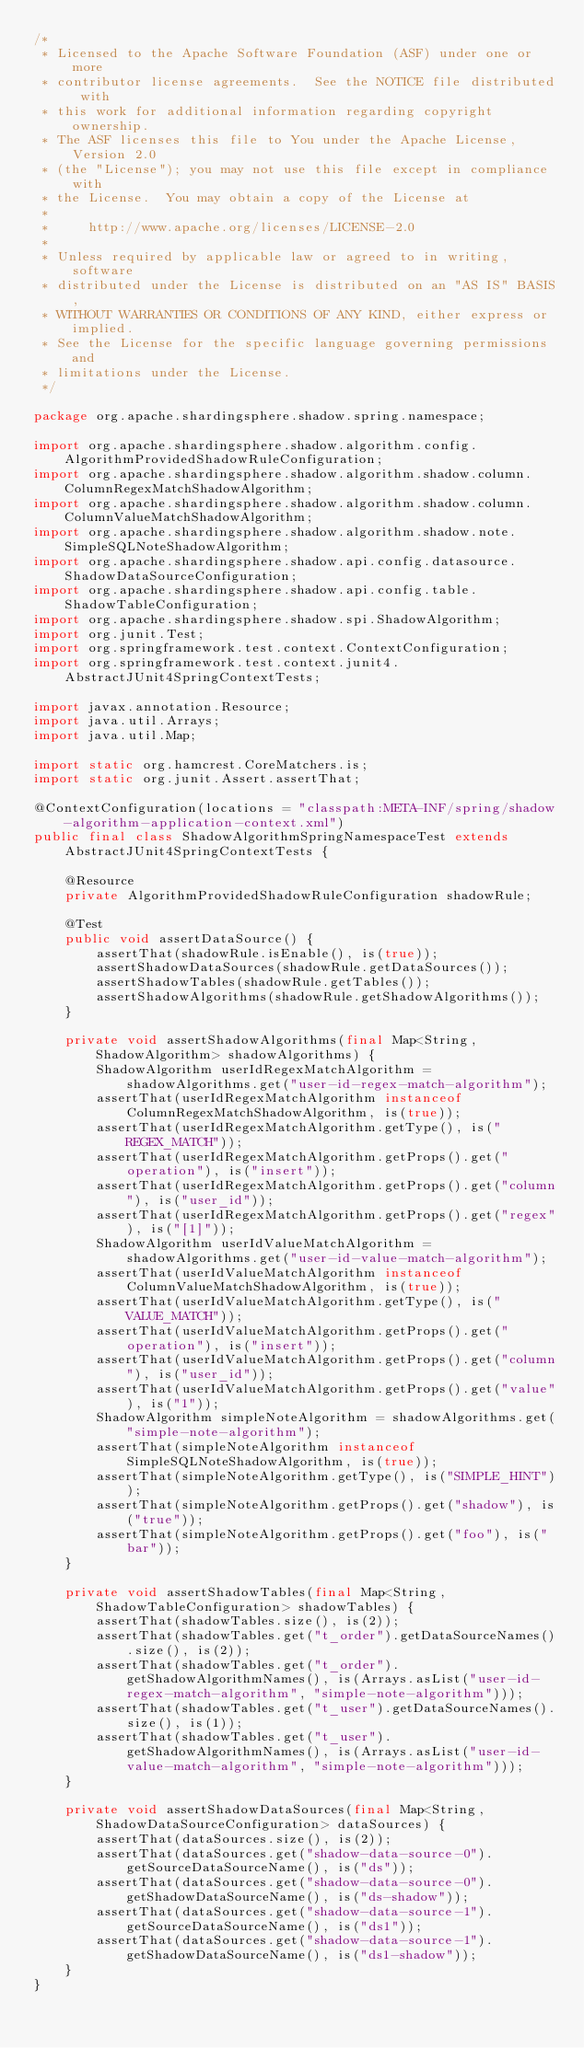<code> <loc_0><loc_0><loc_500><loc_500><_Java_>/*
 * Licensed to the Apache Software Foundation (ASF) under one or more
 * contributor license agreements.  See the NOTICE file distributed with
 * this work for additional information regarding copyright ownership.
 * The ASF licenses this file to You under the Apache License, Version 2.0
 * (the "License"); you may not use this file except in compliance with
 * the License.  You may obtain a copy of the License at
 *
 *     http://www.apache.org/licenses/LICENSE-2.0
 *
 * Unless required by applicable law or agreed to in writing, software
 * distributed under the License is distributed on an "AS IS" BASIS,
 * WITHOUT WARRANTIES OR CONDITIONS OF ANY KIND, either express or implied.
 * See the License for the specific language governing permissions and
 * limitations under the License.
 */

package org.apache.shardingsphere.shadow.spring.namespace;

import org.apache.shardingsphere.shadow.algorithm.config.AlgorithmProvidedShadowRuleConfiguration;
import org.apache.shardingsphere.shadow.algorithm.shadow.column.ColumnRegexMatchShadowAlgorithm;
import org.apache.shardingsphere.shadow.algorithm.shadow.column.ColumnValueMatchShadowAlgorithm;
import org.apache.shardingsphere.shadow.algorithm.shadow.note.SimpleSQLNoteShadowAlgorithm;
import org.apache.shardingsphere.shadow.api.config.datasource.ShadowDataSourceConfiguration;
import org.apache.shardingsphere.shadow.api.config.table.ShadowTableConfiguration;
import org.apache.shardingsphere.shadow.spi.ShadowAlgorithm;
import org.junit.Test;
import org.springframework.test.context.ContextConfiguration;
import org.springframework.test.context.junit4.AbstractJUnit4SpringContextTests;

import javax.annotation.Resource;
import java.util.Arrays;
import java.util.Map;

import static org.hamcrest.CoreMatchers.is;
import static org.junit.Assert.assertThat;

@ContextConfiguration(locations = "classpath:META-INF/spring/shadow-algorithm-application-context.xml")
public final class ShadowAlgorithmSpringNamespaceTest extends AbstractJUnit4SpringContextTests {
    
    @Resource
    private AlgorithmProvidedShadowRuleConfiguration shadowRule;
    
    @Test
    public void assertDataSource() {
        assertThat(shadowRule.isEnable(), is(true));
        assertShadowDataSources(shadowRule.getDataSources());
        assertShadowTables(shadowRule.getTables());
        assertShadowAlgorithms(shadowRule.getShadowAlgorithms());
    }
    
    private void assertShadowAlgorithms(final Map<String, ShadowAlgorithm> shadowAlgorithms) {
        ShadowAlgorithm userIdRegexMatchAlgorithm = shadowAlgorithms.get("user-id-regex-match-algorithm");
        assertThat(userIdRegexMatchAlgorithm instanceof ColumnRegexMatchShadowAlgorithm, is(true));
        assertThat(userIdRegexMatchAlgorithm.getType(), is("REGEX_MATCH"));
        assertThat(userIdRegexMatchAlgorithm.getProps().get("operation"), is("insert"));
        assertThat(userIdRegexMatchAlgorithm.getProps().get("column"), is("user_id"));
        assertThat(userIdRegexMatchAlgorithm.getProps().get("regex"), is("[1]"));
        ShadowAlgorithm userIdValueMatchAlgorithm = shadowAlgorithms.get("user-id-value-match-algorithm");
        assertThat(userIdValueMatchAlgorithm instanceof ColumnValueMatchShadowAlgorithm, is(true));
        assertThat(userIdValueMatchAlgorithm.getType(), is("VALUE_MATCH"));
        assertThat(userIdValueMatchAlgorithm.getProps().get("operation"), is("insert"));
        assertThat(userIdValueMatchAlgorithm.getProps().get("column"), is("user_id"));
        assertThat(userIdValueMatchAlgorithm.getProps().get("value"), is("1"));
        ShadowAlgorithm simpleNoteAlgorithm = shadowAlgorithms.get("simple-note-algorithm");
        assertThat(simpleNoteAlgorithm instanceof SimpleSQLNoteShadowAlgorithm, is(true));
        assertThat(simpleNoteAlgorithm.getType(), is("SIMPLE_HINT"));
        assertThat(simpleNoteAlgorithm.getProps().get("shadow"), is("true"));
        assertThat(simpleNoteAlgorithm.getProps().get("foo"), is("bar"));
    }
    
    private void assertShadowTables(final Map<String, ShadowTableConfiguration> shadowTables) {
        assertThat(shadowTables.size(), is(2));
        assertThat(shadowTables.get("t_order").getDataSourceNames().size(), is(2));
        assertThat(shadowTables.get("t_order").getShadowAlgorithmNames(), is(Arrays.asList("user-id-regex-match-algorithm", "simple-note-algorithm")));
        assertThat(shadowTables.get("t_user").getDataSourceNames().size(), is(1));
        assertThat(shadowTables.get("t_user").getShadowAlgorithmNames(), is(Arrays.asList("user-id-value-match-algorithm", "simple-note-algorithm")));
    }
    
    private void assertShadowDataSources(final Map<String, ShadowDataSourceConfiguration> dataSources) {
        assertThat(dataSources.size(), is(2));
        assertThat(dataSources.get("shadow-data-source-0").getSourceDataSourceName(), is("ds"));
        assertThat(dataSources.get("shadow-data-source-0").getShadowDataSourceName(), is("ds-shadow"));
        assertThat(dataSources.get("shadow-data-source-1").getSourceDataSourceName(), is("ds1"));
        assertThat(dataSources.get("shadow-data-source-1").getShadowDataSourceName(), is("ds1-shadow"));
    }
}
</code> 